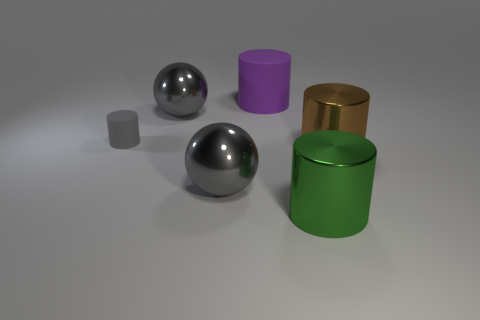Is there any other thing that has the same size as the gray matte cylinder?
Provide a short and direct response. No. How many purple objects have the same material as the gray cylinder?
Ensure brevity in your answer.  1. There is a matte object in front of the large purple rubber object; what is its shape?
Ensure brevity in your answer.  Cylinder. Are the big gray thing that is in front of the gray matte cylinder and the large object right of the green thing made of the same material?
Offer a very short reply. Yes. Are there any green objects that have the same shape as the large brown shiny thing?
Ensure brevity in your answer.  Yes. What number of things are either big shiny things that are behind the small matte thing or tiny brown balls?
Your answer should be very brief. 1. Is the number of green objects on the right side of the brown shiny cylinder greater than the number of big purple matte objects right of the green object?
Offer a very short reply. No. What number of rubber objects are cylinders or large yellow balls?
Make the answer very short. 2. Is the number of large green cylinders behind the large green metal cylinder less than the number of balls behind the small cylinder?
Keep it short and to the point. Yes. What number of objects are either tiny red metal balls or big cylinders on the right side of the big green thing?
Provide a succinct answer. 1. 